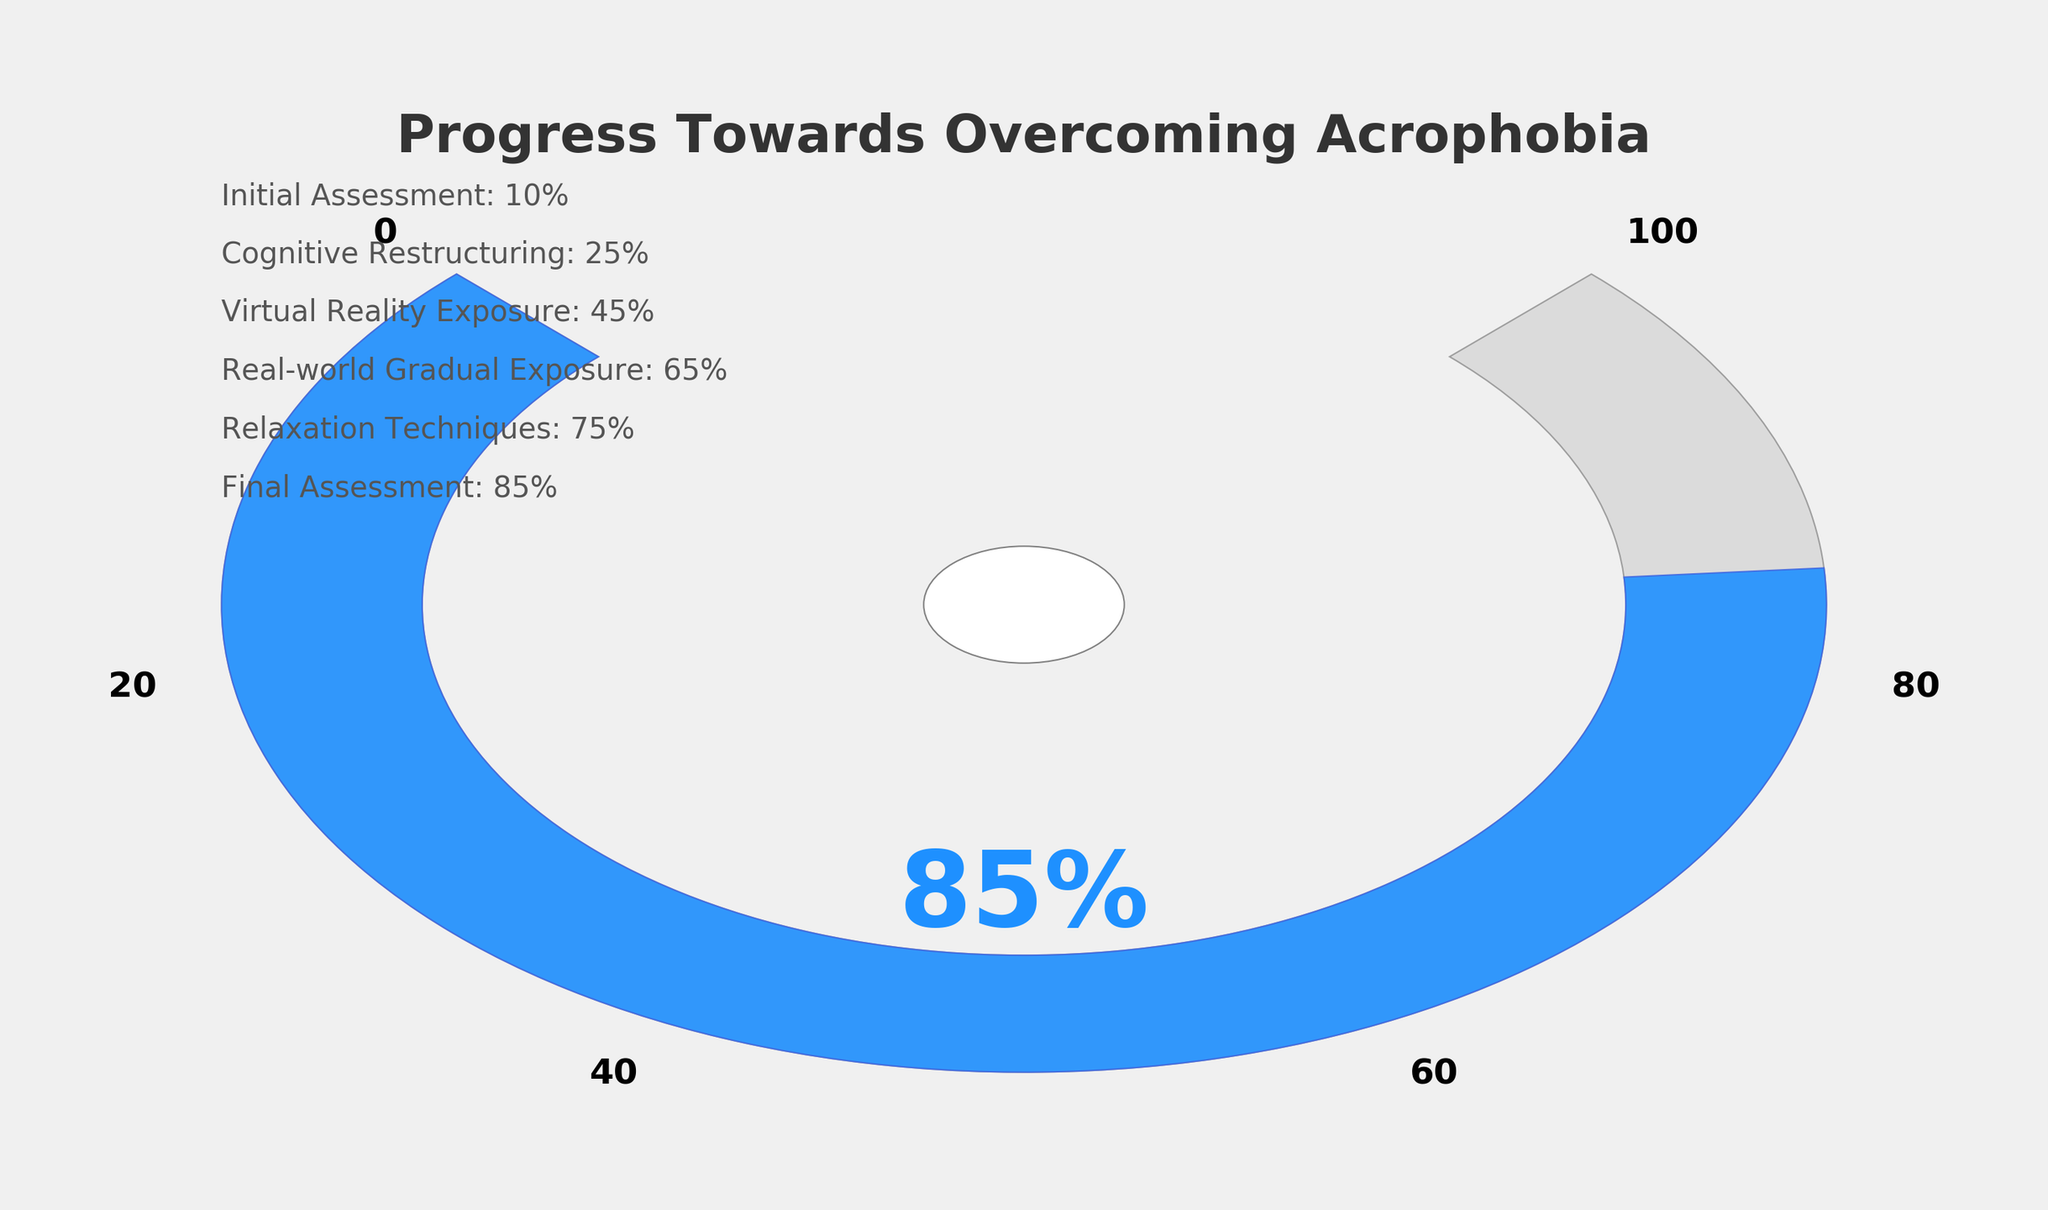What's the title of the figure? The title of the figure is displayed prominently at the top of the gauge chart.
Answer: Progress Towards Overcoming Acrophobia What is the final progress percentage indicated on the chart? The percentage shown prominently in large text near the center bottom part of the gauge chart represents the final progress.
Answer: 85% How many sessions are listed in the figure? By counting the number of session labels provided on the left side of the chart, we can determine how many therapy sessions are documented.
Answer: 6 What's the percentage progress seen after the Cognitive Restructuring session? The left side of the chart lists individual sessions with their corresponding progress percentages. The Cognitive Restructuring session is listed second with its progress.
Answer: 25% How much progress was made from the Virtual Reality Exposure to the Final Assessment session? To find this, subtract the progress percentage at the Virtual Reality Exposure session from that at the Final Assessment session, i.e., 85% - 45% = 40%.
Answer: 40% Which session shows the least progress? The session with the lowest progress percentage listed on the left side of the chart shows the least progress.
Answer: Initial Assessment Is the progress rate more intensive towards the beginning or end of the sessions? By observing the differences between consecutive sessions, we can compare the frequency of progress increases. Larger progress increments in later sessions, such as from Real-world Gradual Exposure to Final Assessment, suggest higher intensity at the end.
Answer: End of the sessions What percentage range is covered by the blue progress marker on the gauge chart? The blue progress marker on the gauge chart extends from the starting angle at 10% progress to its end at 85% progress.
Answer: 10% to 85% Rank the sessions from highest to lowest in terms of progress percentage. Listing the sessions in order based on the percentage values given beside each session label on the left side of the chart will show the ranking. The order is: Final Assessment (85%), Relaxation Techniques (75%), Real-world Gradual Exposure (65%), Virtual Reality Exposure (45%), Cognitive Restructuring (25%), and Initial Assessment (10%).
Answer: Final Assessment, Relaxation Techniques, Real-world Gradual Exposure, Virtual Reality Exposure, Cognitive Restructuring, Initial Assessment How does the gauge chart visually indicate progress through therapy sessions? The chart uses a colored wedge that fills part of the circular gauge, going from gray to blue as progress is made, alongside a percentage label in the center and specific session progress listed on the side. Bold text on the gauge also helps to indicate varying progress levels visually.
Answer: Through a colored wedge and percentage labels 